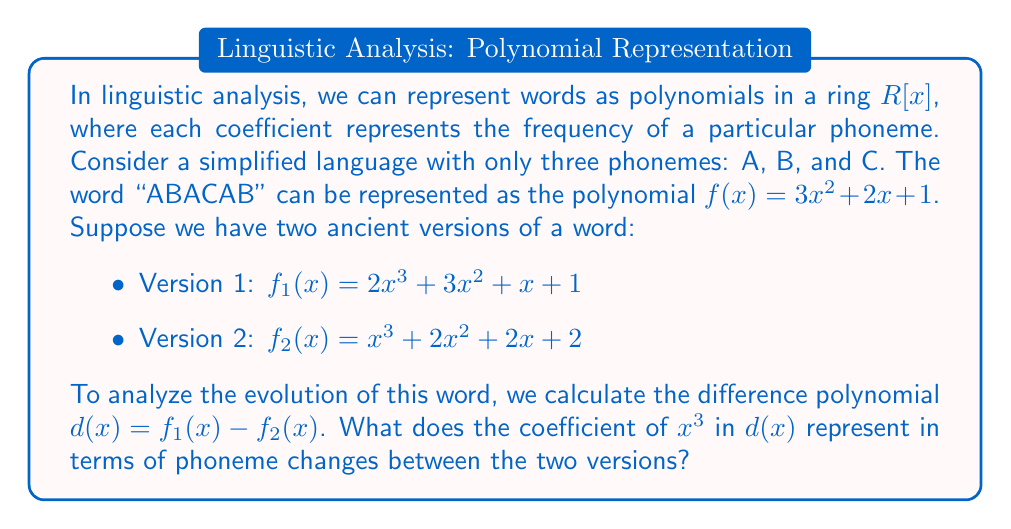Teach me how to tackle this problem. Let's approach this step-by-step:

1) First, we need to understand what the polynomials represent:
   - The coefficient of $x^3$ represents the frequency of phoneme A
   - The coefficient of $x^2$ represents the frequency of phoneme B
   - The coefficient of $x$ represents the frequency of phoneme C
   - The constant term represents the frequency of any other phonemes

2) Now, let's calculate the difference polynomial $d(x)$:

   $d(x) = f_1(x) - f_2(x)$
   $d(x) = (2x^3 + 3x^2 + x + 1) - (x^3 + 2x^2 + 2x + 2)$

3) Simplifying:

   $d(x) = x^3 + x^2 - x - 1$

4) Looking at the coefficient of $x^3$ in $d(x)$, we see it's 1.

5) This means that Version 1 has one more A phoneme than Version 2.

6) In linguistic terms, this represents a gain of one A phoneme in Version 1 compared to Version 2, or alternatively, a loss of one A phoneme in Version 2 compared to Version 1.

This method allows linguists to quantify and analyze phoneme changes between different versions or stages of a word, providing insights into language evolution.
Answer: Gain of one A phoneme in Version 1 (or loss of one A phoneme in Version 2) 